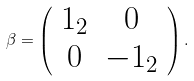<formula> <loc_0><loc_0><loc_500><loc_500>\beta = \left ( \begin{array} { c c } { 1 _ { 2 } } & { 0 } \\ { 0 } & { - 1 _ { 2 } } \end{array} \right ) .</formula> 